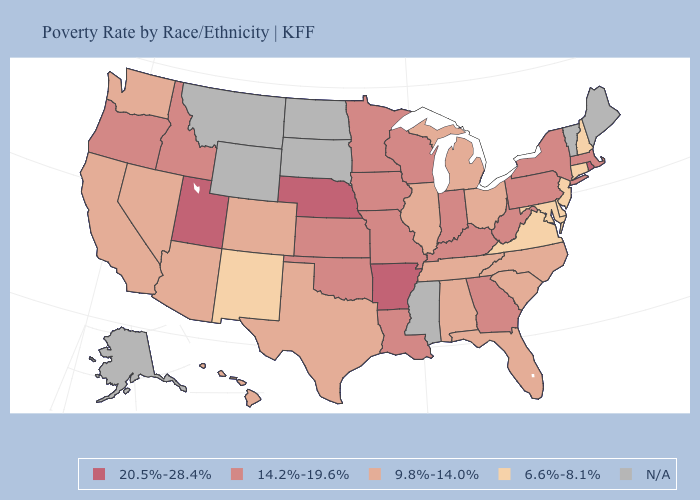Is the legend a continuous bar?
Short answer required. No. Is the legend a continuous bar?
Short answer required. No. Does Michigan have the highest value in the MidWest?
Short answer required. No. What is the highest value in the USA?
Write a very short answer. 20.5%-28.4%. Does Kentucky have the highest value in the South?
Write a very short answer. No. Name the states that have a value in the range 9.8%-14.0%?
Quick response, please. Alabama, Arizona, California, Colorado, Florida, Hawaii, Illinois, Michigan, Nevada, North Carolina, Ohio, South Carolina, Tennessee, Texas, Washington. What is the lowest value in the Northeast?
Short answer required. 6.6%-8.1%. Among the states that border Missouri , which have the lowest value?
Write a very short answer. Illinois, Tennessee. Name the states that have a value in the range 9.8%-14.0%?
Answer briefly. Alabama, Arizona, California, Colorado, Florida, Hawaii, Illinois, Michigan, Nevada, North Carolina, Ohio, South Carolina, Tennessee, Texas, Washington. Name the states that have a value in the range N/A?
Keep it brief. Alaska, Maine, Mississippi, Montana, North Dakota, South Dakota, Vermont, Wyoming. Is the legend a continuous bar?
Write a very short answer. No. What is the value of California?
Keep it brief. 9.8%-14.0%. Name the states that have a value in the range 20.5%-28.4%?
Concise answer only. Arkansas, Nebraska, Rhode Island, Utah. Name the states that have a value in the range 20.5%-28.4%?
Answer briefly. Arkansas, Nebraska, Rhode Island, Utah. 